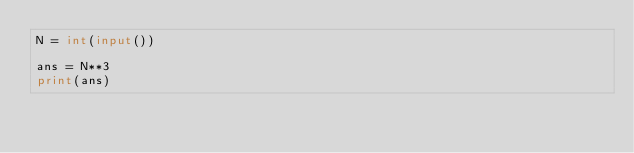<code> <loc_0><loc_0><loc_500><loc_500><_Python_>N = int(input())

ans = N**3
print(ans)</code> 